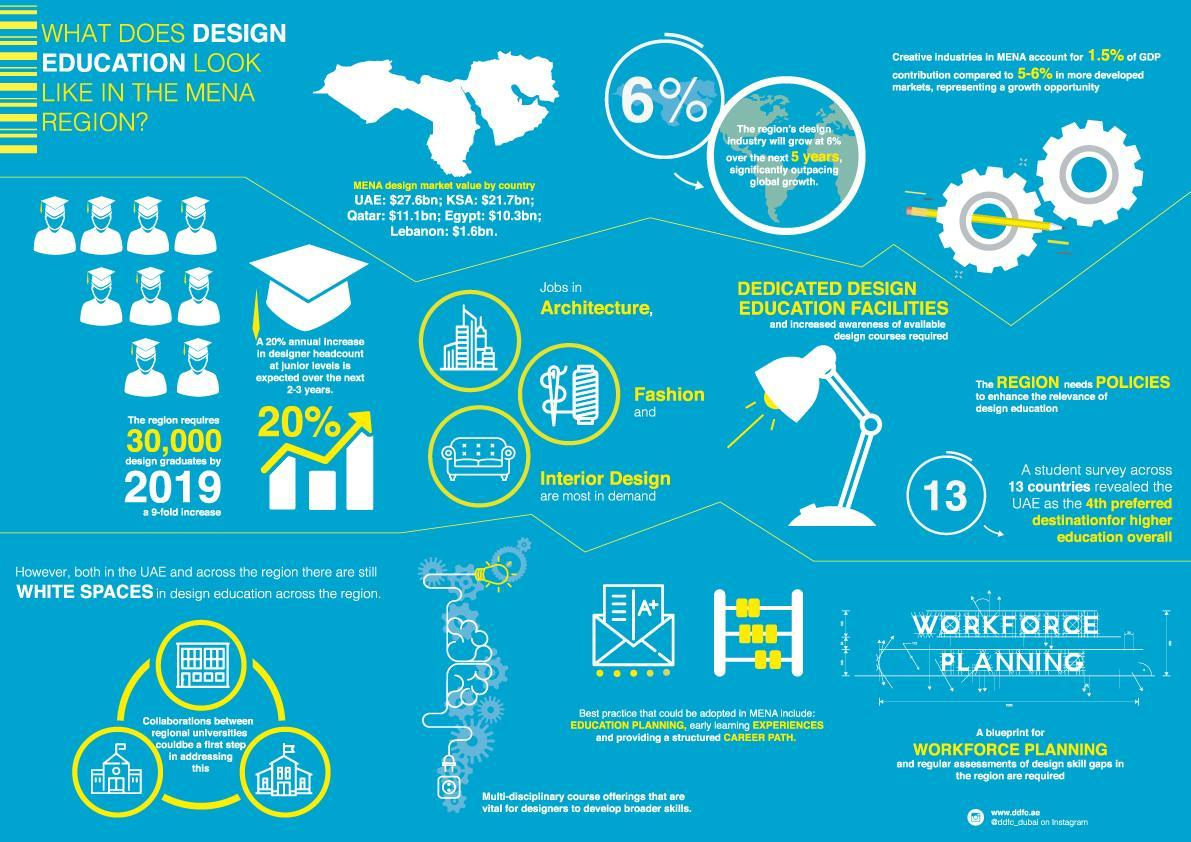What is the combined MENA design market value for KSA and Egypt?
Answer the question with a short phrase. $32bn What is the combined MENA design market value for KSA and Lebanon? $23.3bn 